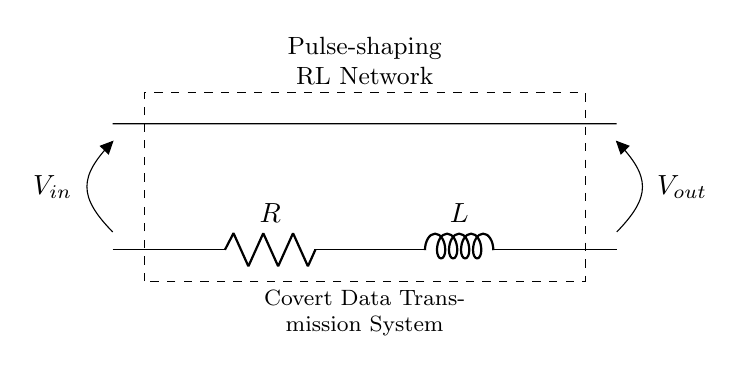What is the type of network shown in the diagram? The diagram describes a pulse-shaping RL network based on the text above the circuit. This indicates it is designed to modify pulse signals, characteristic of its components - a resistor and an inductor.
Answer: Pulse-shaping RL network What components are used in this circuit? The circuit consists of a resistor (R) and an inductor (L), as indicated by the labeled symbols in the diagram. These two components are crucial for the function of the pulse-shaping network.
Answer: Resistor and inductor What is connected to the input of this circuit? The input marked as V_in is connected to an open point which serves as an input voltage supply, leading into the resistor. This connection demonstrates where the signal enters the RL network.
Answer: Input voltage V_in What does the output voltage represent in this circuit? The output voltage, V_out, as indicated at the open point at the end of the circuit, represents the voltage signal that has been shaped or modified by the RL network. This denotes the desired signal to be extracted.
Answer: Output voltage V_out How does the inductor influence the signal in this circuit? The inductor in this RL network influences the signal primarily by introducing a phase shift and storing energy in its magnetic field, which is essential in pulse-shaping applications. Its inherent properties allow for filtering and smoothing of the output signal.
Answer: Introduces phase shift What happens to the signal as it passes through the resistor and inductor? As the signal passes through the resistor, it experiences a certain level of resistive loss and phase shift introduced by the inductor. This combination alters the signal's amplitude and shape, resulting in a modified output suitable for transmission.
Answer: Signal modifies and shapes What is the main purpose of this RL network in covert data transmission? The primary purpose of this RL network in covert data transmission is to shape the pulses of the transmitted data, making it more difficult to detect by ensuring that the signals blend into the noise of the surrounding environment.
Answer: Covert data transmission 